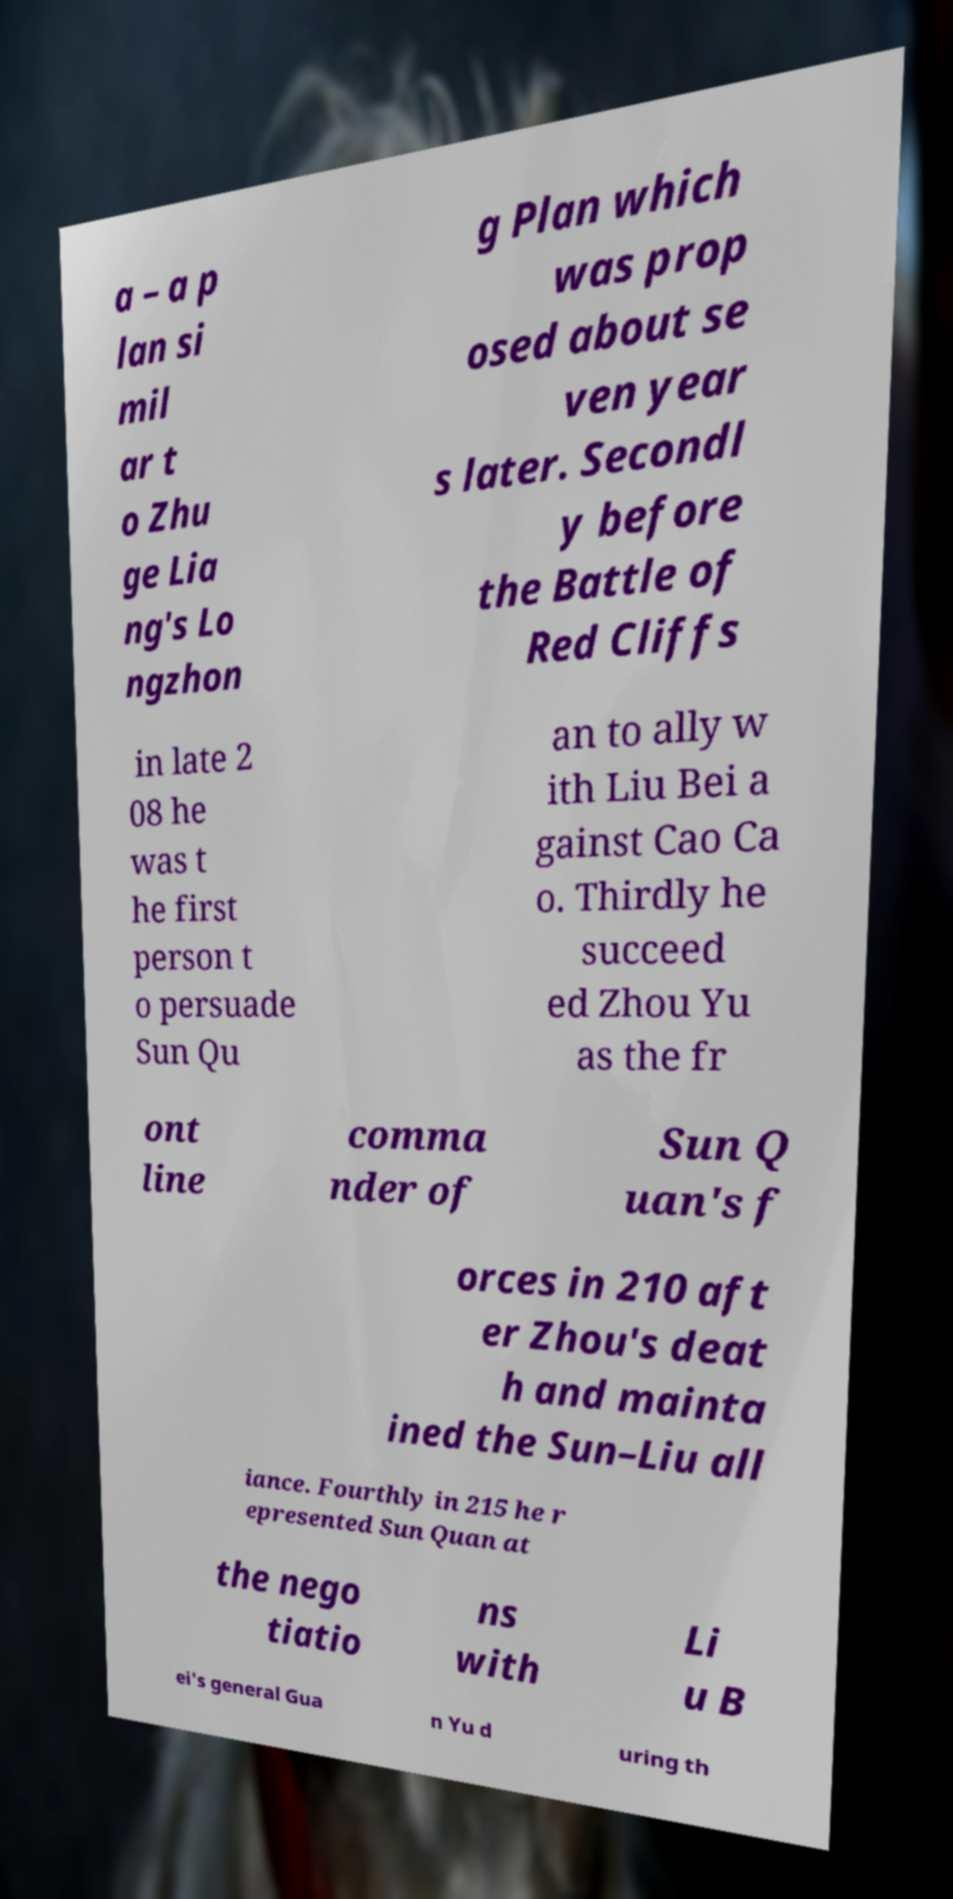Can you accurately transcribe the text from the provided image for me? a – a p lan si mil ar t o Zhu ge Lia ng's Lo ngzhon g Plan which was prop osed about se ven year s later. Secondl y before the Battle of Red Cliffs in late 2 08 he was t he first person t o persuade Sun Qu an to ally w ith Liu Bei a gainst Cao Ca o. Thirdly he succeed ed Zhou Yu as the fr ont line comma nder of Sun Q uan's f orces in 210 aft er Zhou's deat h and mainta ined the Sun–Liu all iance. Fourthly in 215 he r epresented Sun Quan at the nego tiatio ns with Li u B ei's general Gua n Yu d uring th 